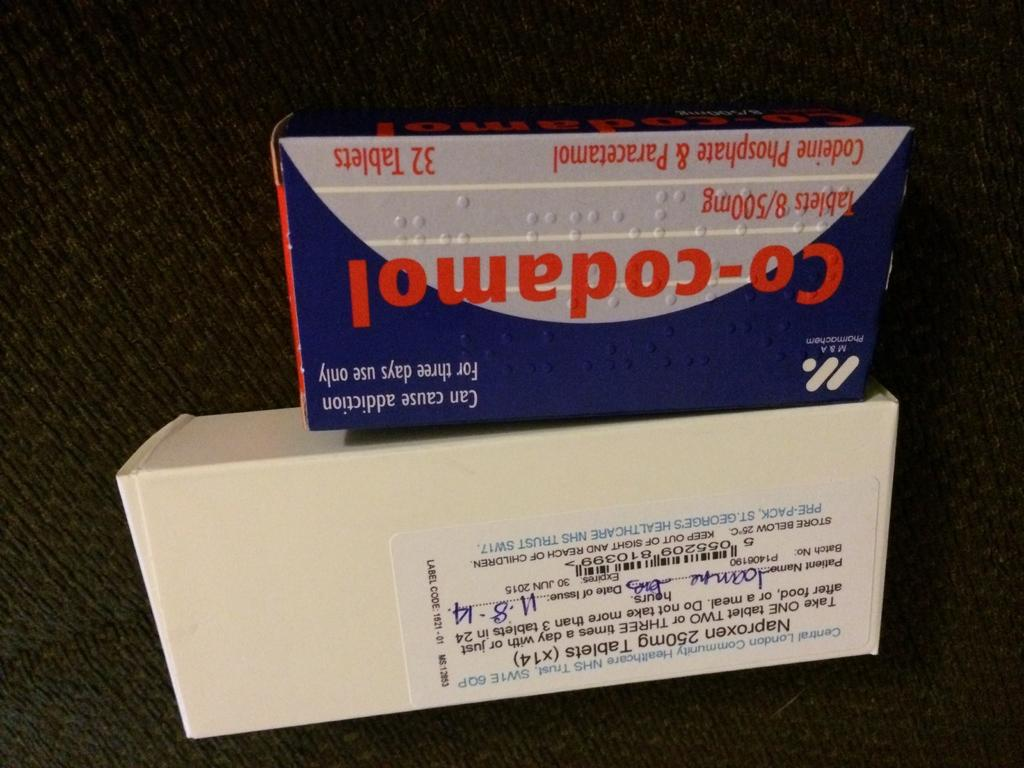Provide a one-sentence caption for the provided image. A box of Naproxen and Co-Codamel tablets issued on 11-8-14. 